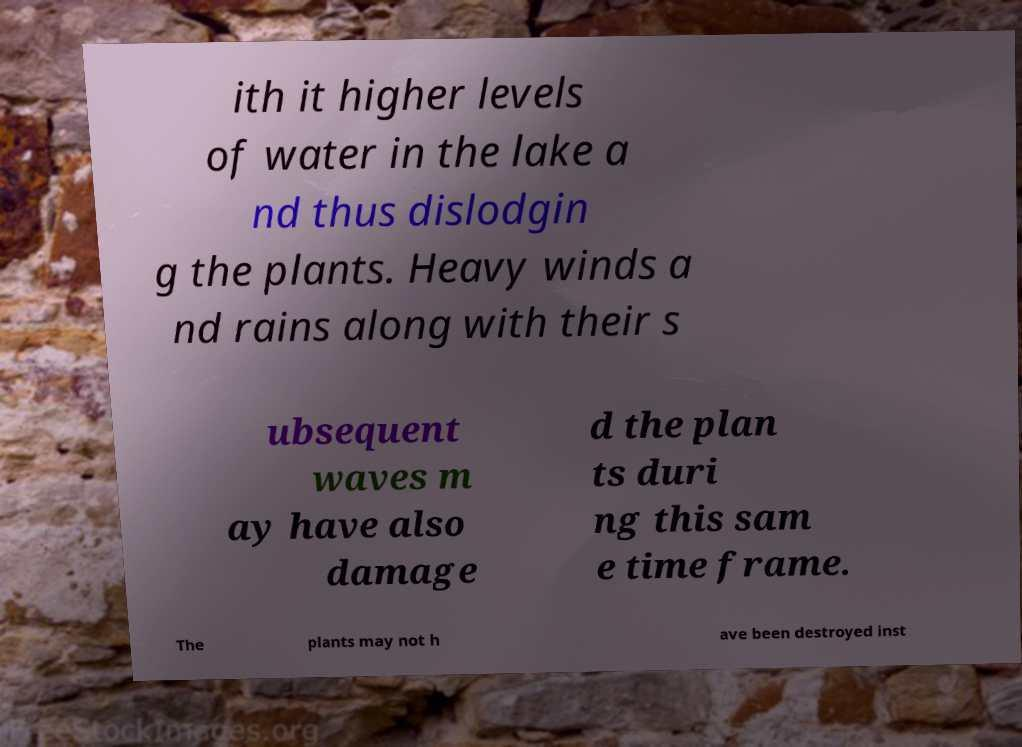There's text embedded in this image that I need extracted. Can you transcribe it verbatim? ith it higher levels of water in the lake a nd thus dislodgin g the plants. Heavy winds a nd rains along with their s ubsequent waves m ay have also damage d the plan ts duri ng this sam e time frame. The plants may not h ave been destroyed inst 